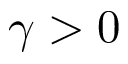Convert formula to latex. <formula><loc_0><loc_0><loc_500><loc_500>\gamma > 0</formula> 